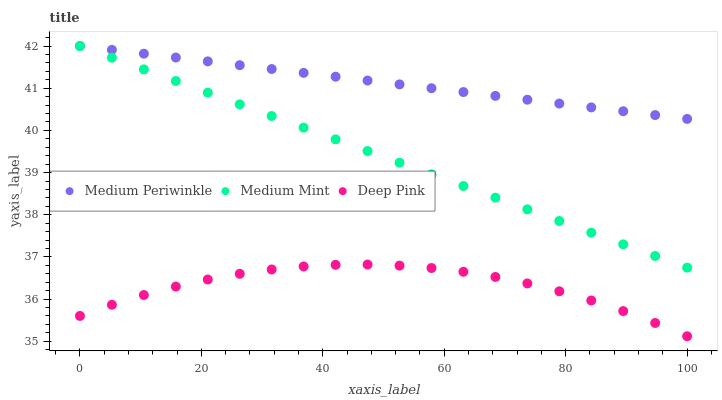Does Deep Pink have the minimum area under the curve?
Answer yes or no. Yes. Does Medium Periwinkle have the maximum area under the curve?
Answer yes or no. Yes. Does Medium Periwinkle have the minimum area under the curve?
Answer yes or no. No. Does Deep Pink have the maximum area under the curve?
Answer yes or no. No. Is Medium Mint the smoothest?
Answer yes or no. Yes. Is Deep Pink the roughest?
Answer yes or no. Yes. Is Medium Periwinkle the smoothest?
Answer yes or no. No. Is Medium Periwinkle the roughest?
Answer yes or no. No. Does Deep Pink have the lowest value?
Answer yes or no. Yes. Does Medium Periwinkle have the lowest value?
Answer yes or no. No. Does Medium Periwinkle have the highest value?
Answer yes or no. Yes. Does Deep Pink have the highest value?
Answer yes or no. No. Is Deep Pink less than Medium Periwinkle?
Answer yes or no. Yes. Is Medium Mint greater than Deep Pink?
Answer yes or no. Yes. Does Medium Periwinkle intersect Medium Mint?
Answer yes or no. Yes. Is Medium Periwinkle less than Medium Mint?
Answer yes or no. No. Is Medium Periwinkle greater than Medium Mint?
Answer yes or no. No. Does Deep Pink intersect Medium Periwinkle?
Answer yes or no. No. 